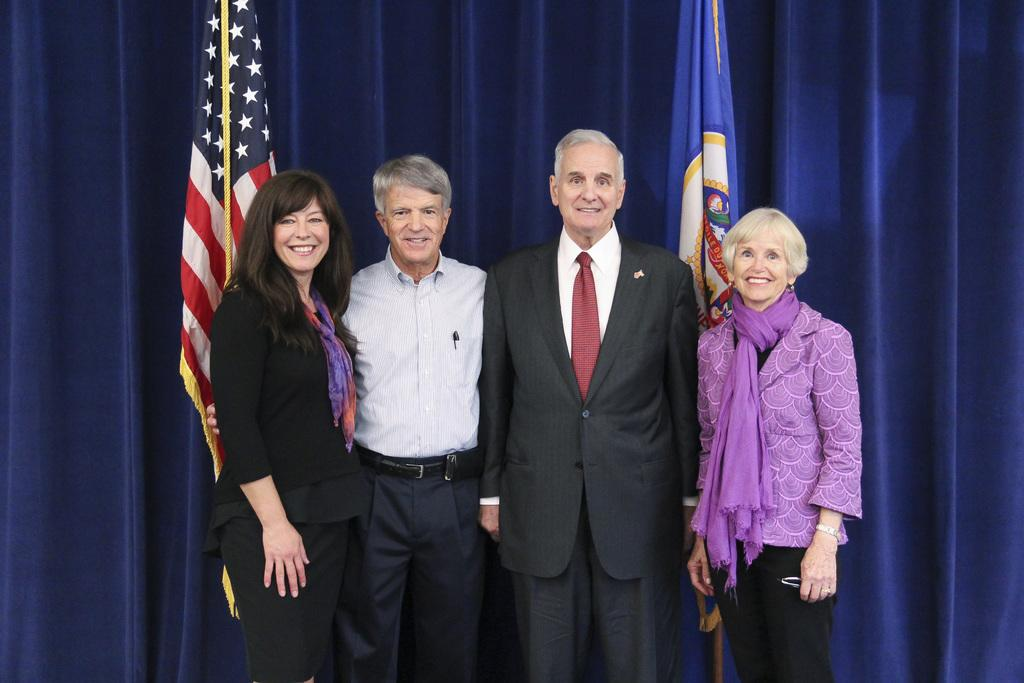What is happening in the image? There is a group of people standing in the image. What can be seen in the background of the image? There are flags visible in the background of the image. What is covering the top part of the image? Curtains are present at the top of the image. What type of wall can be seen in the image? There is no wall present in the image. 